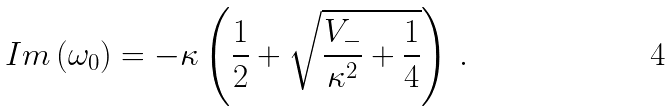Convert formula to latex. <formula><loc_0><loc_0><loc_500><loc_500>I m \left ( \omega _ { 0 } \right ) = - \kappa \left ( \frac { 1 } { 2 } + \sqrt { \frac { V _ { - } } { \kappa ^ { 2 } } + \frac { 1 } { 4 } } \right ) \, .</formula> 